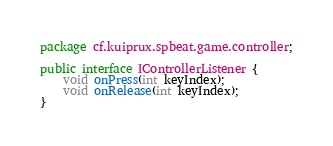<code> <loc_0><loc_0><loc_500><loc_500><_Java_>package cf.kuiprux.spbeat.game.controller;

public interface IControllerListener {
	void onPress(int keyIndex);
	void onRelease(int keyIndex);
}
</code> 